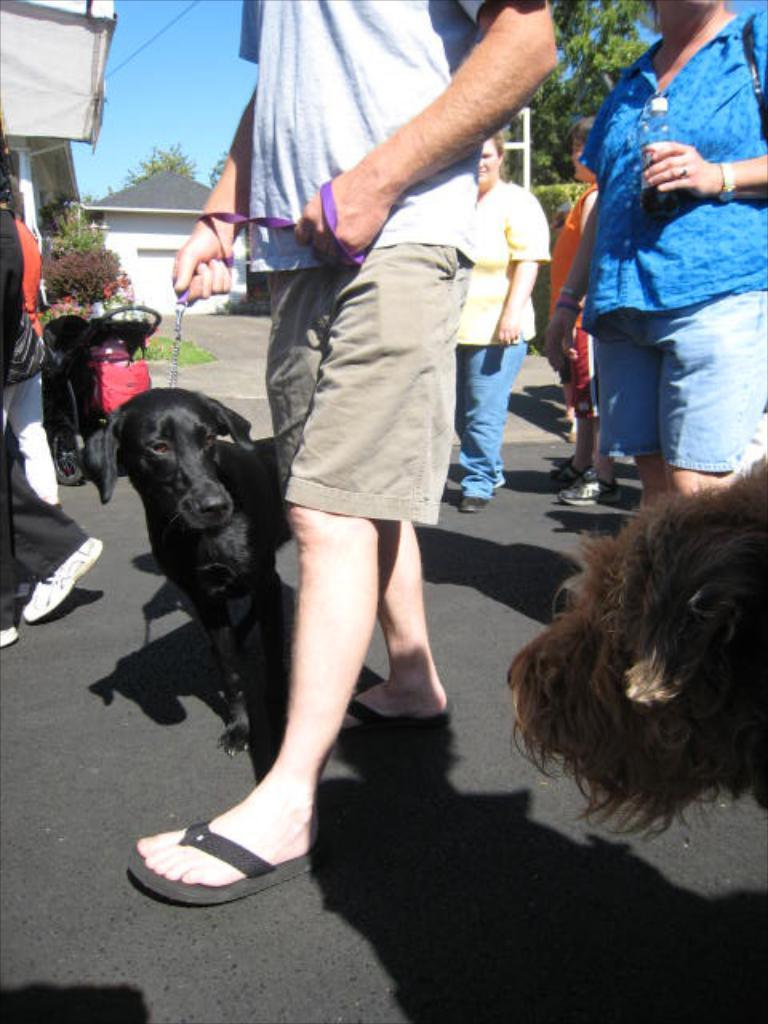How many people are in the image? There is a group of people in the image. What are the people in the image doing? The people are walking on a road. Are there any animals accompanying the people? Yes, there are dogs accompanying the people. What can be seen in the background of the image? There are houses, trees, the sky, wires, and a stroller in the background of the image. How many babies are in the tub in the image? There is no tub or babies present in the image. 